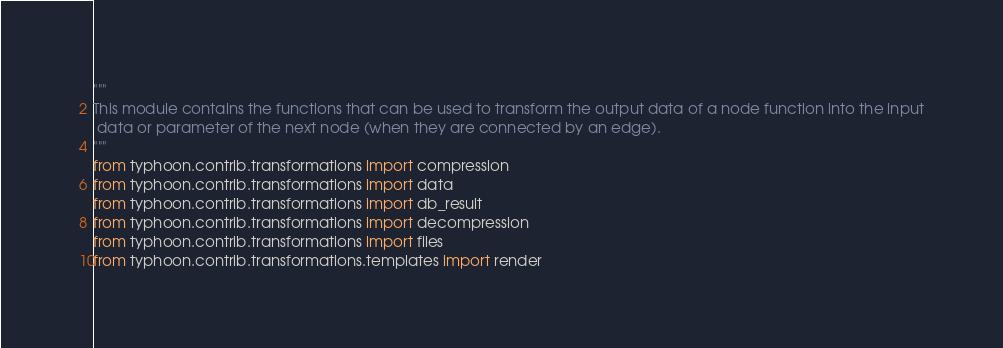Convert code to text. <code><loc_0><loc_0><loc_500><loc_500><_Python_>"""
This module contains the functions that can be used to transform the output data of a node function into the input
 data or parameter of the next node (when they are connected by an edge).
"""
from typhoon.contrib.transformations import compression
from typhoon.contrib.transformations import data
from typhoon.contrib.transformations import db_result
from typhoon.contrib.transformations import decompression
from typhoon.contrib.transformations import files
from typhoon.contrib.transformations.templates import render
</code> 